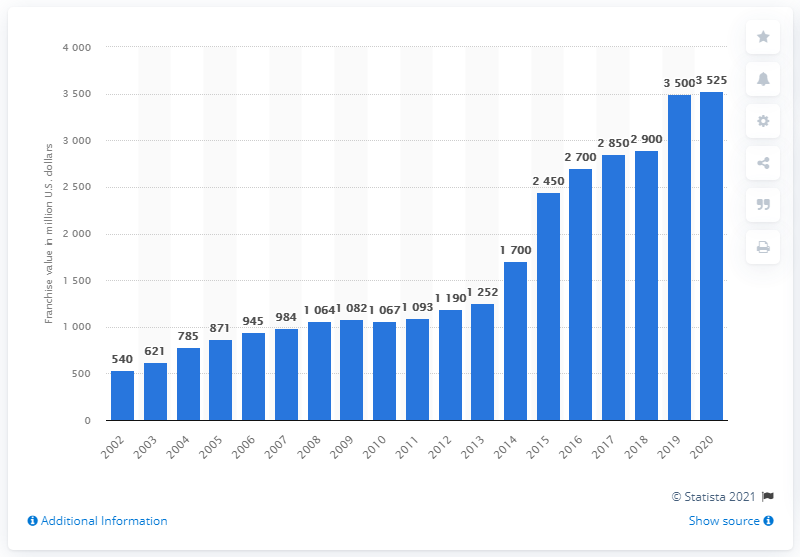Give some essential details in this illustration. In 2020, the Chicago Bears' franchise value was 3,525. 